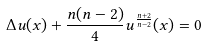<formula> <loc_0><loc_0><loc_500><loc_500>\Delta u ( x ) + \frac { n ( n - 2 ) } { 4 } u ^ { \frac { n + 2 } { n - 2 } } ( x ) = 0</formula> 